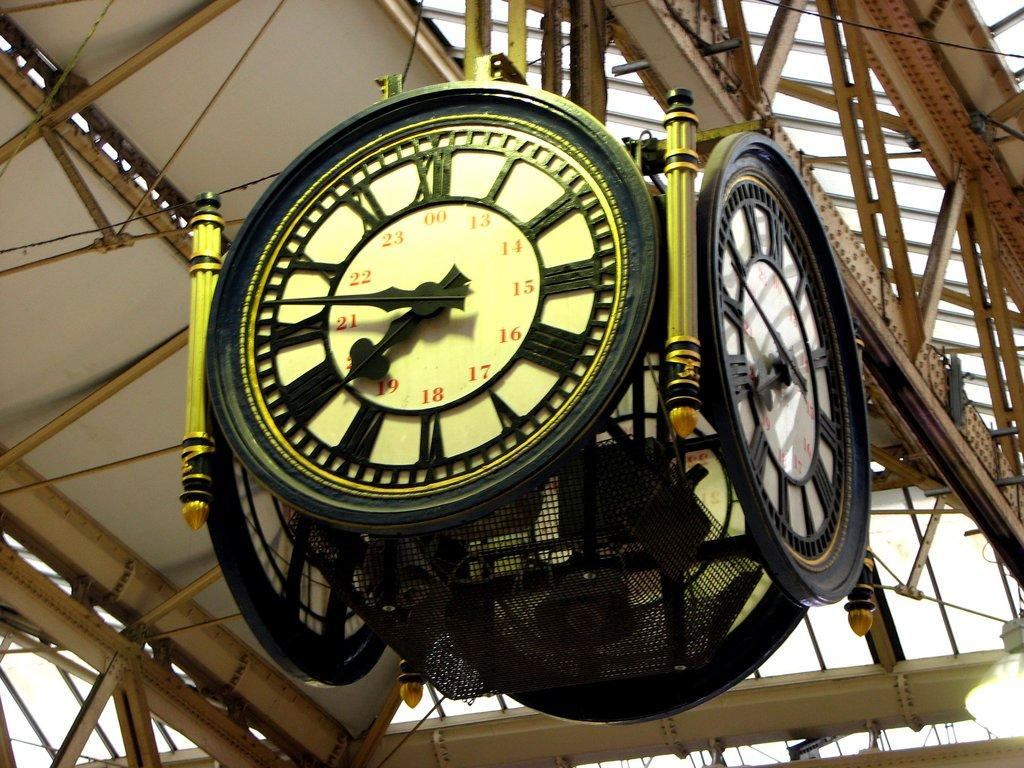<image>
Give a short and clear explanation of the subsequent image. An analog 24 hour four faced clock hanging from the inside a building hanging from rafters 